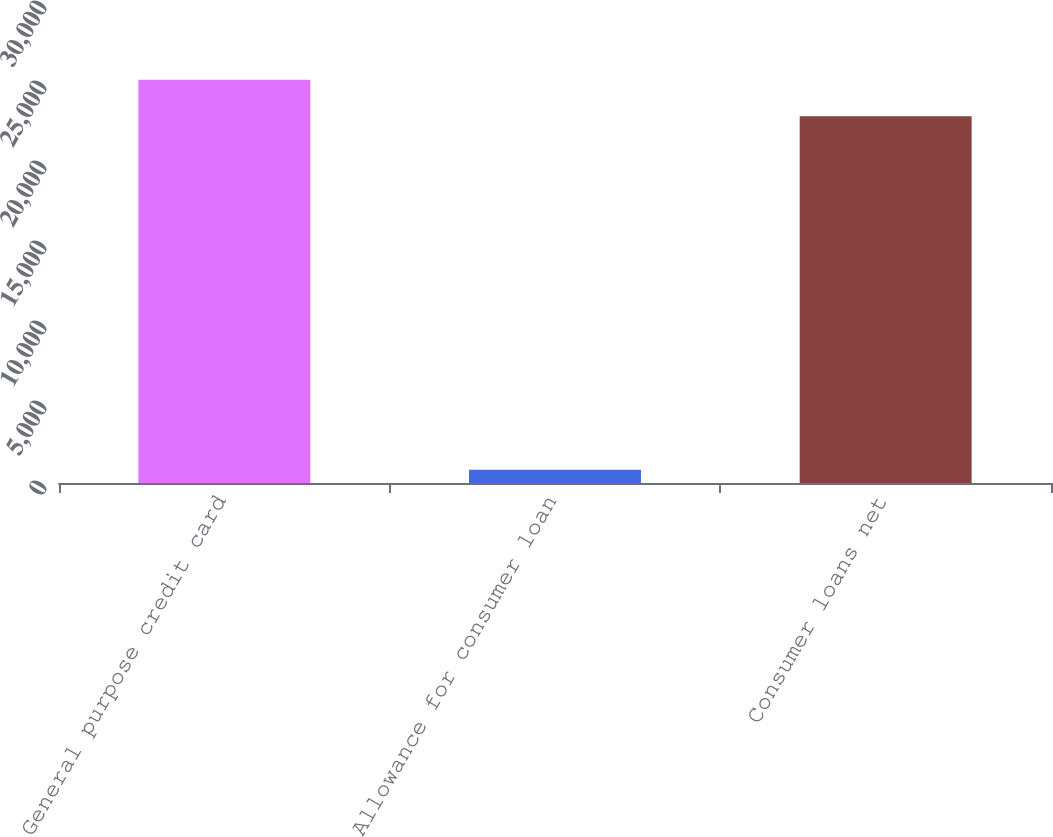Convert chart to OTSL. <chart><loc_0><loc_0><loc_500><loc_500><bar_chart><fcel>General purpose credit card<fcel>Allowance for consumer loan<fcel>Consumer loans net<nl><fcel>25206.5<fcel>831<fcel>22915<nl></chart> 